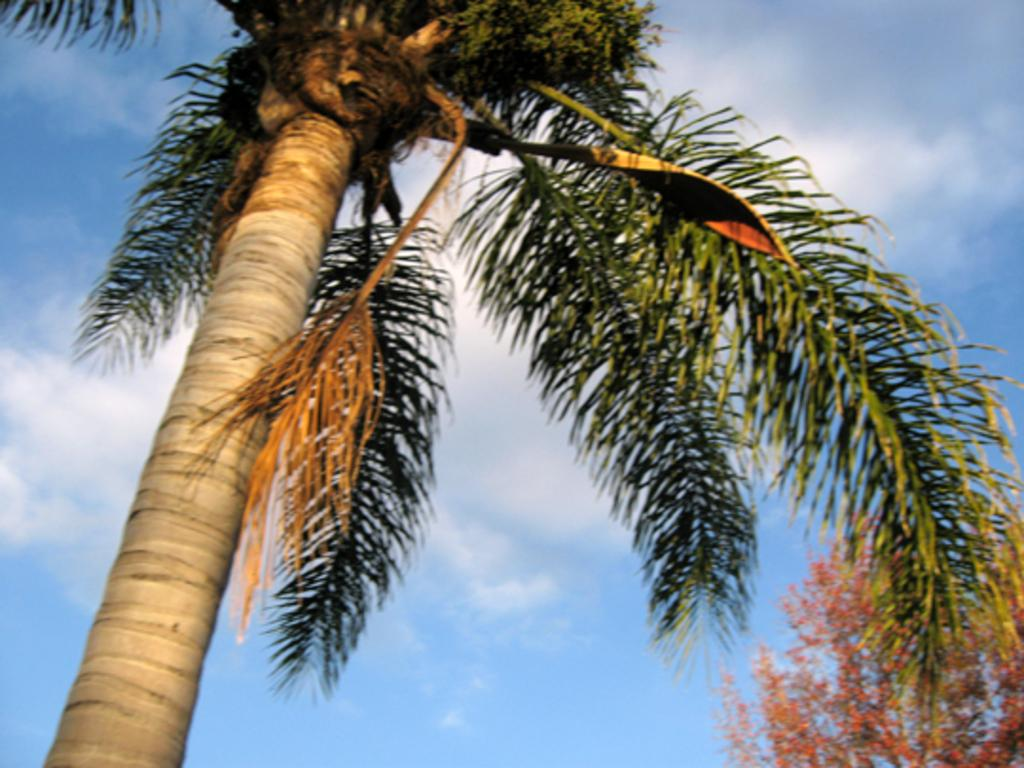What type of vegetation can be seen in the image? There are trees in the image. What else is visible in the sky besides the trees? There are clouds in the image. What part of the natural environment is visible in the image? The sky is visible in the image. What type of fruit is hanging from the trees in the image? There is no fruit visible in the image; only trees and clouds can be seen. 